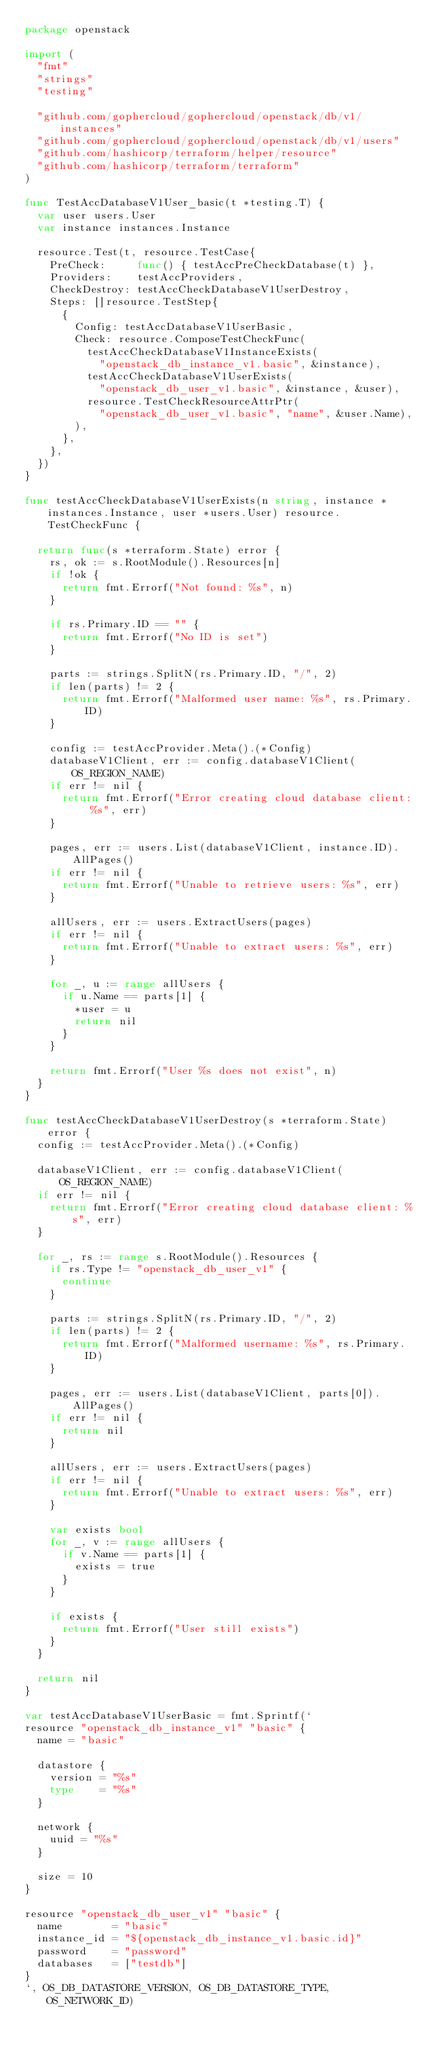<code> <loc_0><loc_0><loc_500><loc_500><_Go_>package openstack

import (
	"fmt"
	"strings"
	"testing"

	"github.com/gophercloud/gophercloud/openstack/db/v1/instances"
	"github.com/gophercloud/gophercloud/openstack/db/v1/users"
	"github.com/hashicorp/terraform/helper/resource"
	"github.com/hashicorp/terraform/terraform"
)

func TestAccDatabaseV1User_basic(t *testing.T) {
	var user users.User
	var instance instances.Instance

	resource.Test(t, resource.TestCase{
		PreCheck:     func() { testAccPreCheckDatabase(t) },
		Providers:    testAccProviders,
		CheckDestroy: testAccCheckDatabaseV1UserDestroy,
		Steps: []resource.TestStep{
			{
				Config: testAccDatabaseV1UserBasic,
				Check: resource.ComposeTestCheckFunc(
					testAccCheckDatabaseV1InstanceExists(
						"openstack_db_instance_v1.basic", &instance),
					testAccCheckDatabaseV1UserExists(
						"openstack_db_user_v1.basic", &instance, &user),
					resource.TestCheckResourceAttrPtr(
						"openstack_db_user_v1.basic", "name", &user.Name),
				),
			},
		},
	})
}

func testAccCheckDatabaseV1UserExists(n string, instance *instances.Instance, user *users.User) resource.TestCheckFunc {

	return func(s *terraform.State) error {
		rs, ok := s.RootModule().Resources[n]
		if !ok {
			return fmt.Errorf("Not found: %s", n)
		}

		if rs.Primary.ID == "" {
			return fmt.Errorf("No ID is set")
		}

		parts := strings.SplitN(rs.Primary.ID, "/", 2)
		if len(parts) != 2 {
			return fmt.Errorf("Malformed user name: %s", rs.Primary.ID)
		}

		config := testAccProvider.Meta().(*Config)
		databaseV1Client, err := config.databaseV1Client(OS_REGION_NAME)
		if err != nil {
			return fmt.Errorf("Error creating cloud database client: %s", err)
		}

		pages, err := users.List(databaseV1Client, instance.ID).AllPages()
		if err != nil {
			return fmt.Errorf("Unable to retrieve users: %s", err)
		}

		allUsers, err := users.ExtractUsers(pages)
		if err != nil {
			return fmt.Errorf("Unable to extract users: %s", err)
		}

		for _, u := range allUsers {
			if u.Name == parts[1] {
				*user = u
				return nil
			}
		}

		return fmt.Errorf("User %s does not exist", n)
	}
}

func testAccCheckDatabaseV1UserDestroy(s *terraform.State) error {
	config := testAccProvider.Meta().(*Config)

	databaseV1Client, err := config.databaseV1Client(OS_REGION_NAME)
	if err != nil {
		return fmt.Errorf("Error creating cloud database client: %s", err)
	}

	for _, rs := range s.RootModule().Resources {
		if rs.Type != "openstack_db_user_v1" {
			continue
		}

		parts := strings.SplitN(rs.Primary.ID, "/", 2)
		if len(parts) != 2 {
			return fmt.Errorf("Malformed username: %s", rs.Primary.ID)
		}

		pages, err := users.List(databaseV1Client, parts[0]).AllPages()
		if err != nil {
			return nil
		}

		allUsers, err := users.ExtractUsers(pages)
		if err != nil {
			return fmt.Errorf("Unable to extract users: %s", err)
		}

		var exists bool
		for _, v := range allUsers {
			if v.Name == parts[1] {
				exists = true
			}
		}

		if exists {
			return fmt.Errorf("User still exists")
		}
	}

	return nil
}

var testAccDatabaseV1UserBasic = fmt.Sprintf(`
resource "openstack_db_instance_v1" "basic" {
  name = "basic"

  datastore {
    version = "%s"
    type    = "%s"
  }

  network {
    uuid = "%s"
  }

  size = 10
}

resource "openstack_db_user_v1" "basic" {
  name        = "basic"
  instance_id = "${openstack_db_instance_v1.basic.id}"
  password    = "password"
  databases   = ["testdb"]
}
`, OS_DB_DATASTORE_VERSION, OS_DB_DATASTORE_TYPE, OS_NETWORK_ID)
</code> 